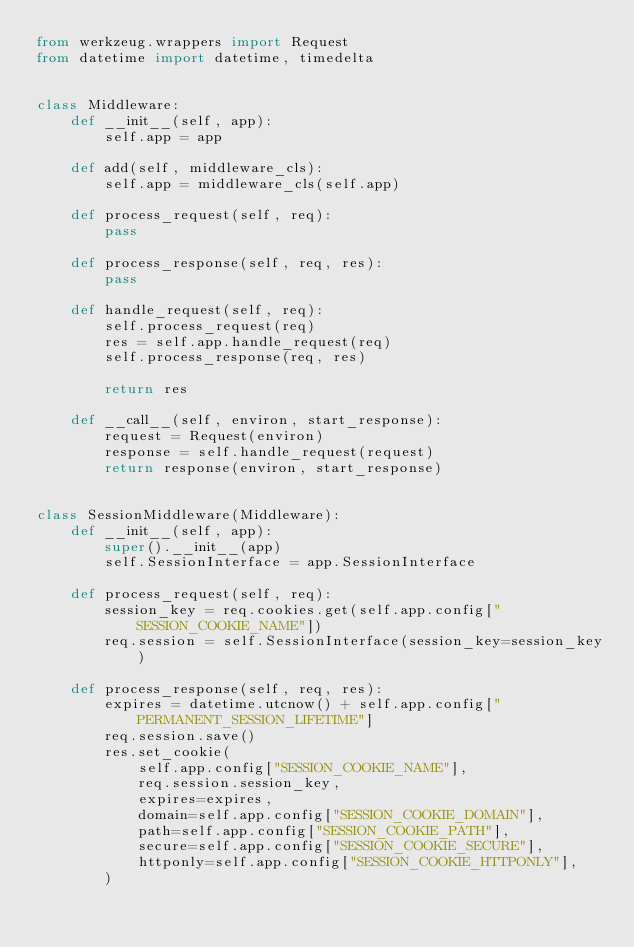<code> <loc_0><loc_0><loc_500><loc_500><_Python_>from werkzeug.wrappers import Request
from datetime import datetime, timedelta


class Middleware:
    def __init__(self, app):
        self.app = app

    def add(self, middleware_cls):
        self.app = middleware_cls(self.app)

    def process_request(self, req):
        pass

    def process_response(self, req, res):
        pass

    def handle_request(self, req):
        self.process_request(req)
        res = self.app.handle_request(req)
        self.process_response(req, res)

        return res

    def __call__(self, environ, start_response):
        request = Request(environ)
        response = self.handle_request(request)
        return response(environ, start_response)


class SessionMiddleware(Middleware):
    def __init__(self, app):
        super().__init__(app)
        self.SessionInterface = app.SessionInterface

    def process_request(self, req):
        session_key = req.cookies.get(self.app.config["SESSION_COOKIE_NAME"])
        req.session = self.SessionInterface(session_key=session_key)

    def process_response(self, req, res):
        expires = datetime.utcnow() + self.app.config["PERMANENT_SESSION_LIFETIME"]
        req.session.save()
        res.set_cookie(
            self.app.config["SESSION_COOKIE_NAME"],
            req.session.session_key,
            expires=expires,
            domain=self.app.config["SESSION_COOKIE_DOMAIN"],
            path=self.app.config["SESSION_COOKIE_PATH"],
            secure=self.app.config["SESSION_COOKIE_SECURE"],
            httponly=self.app.config["SESSION_COOKIE_HTTPONLY"],
        )
</code> 